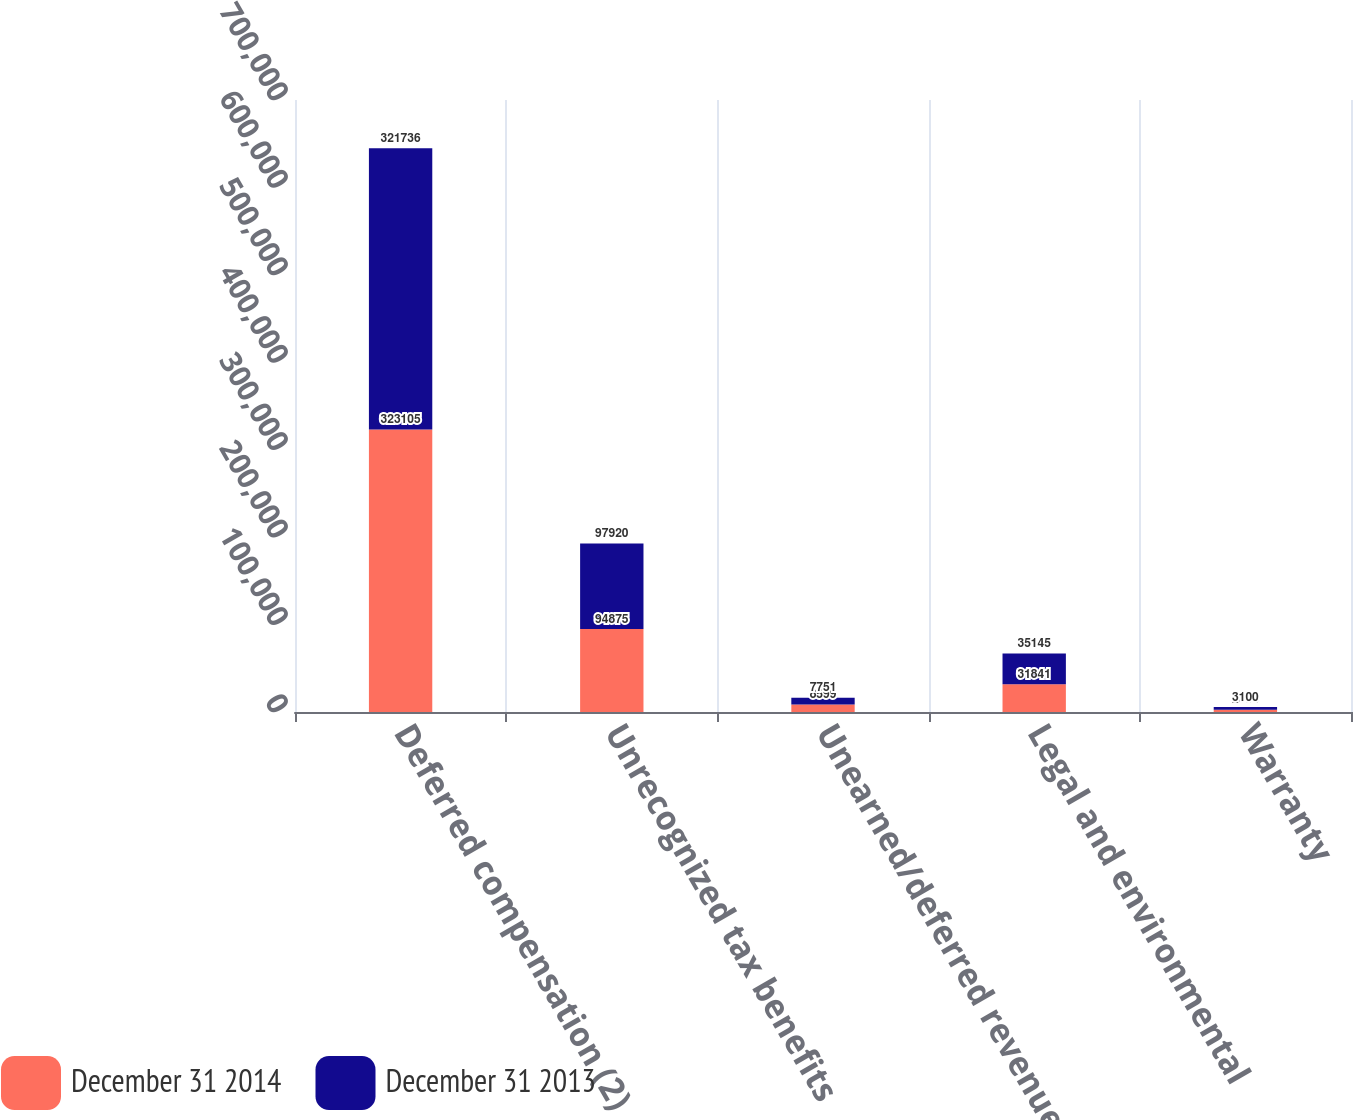<chart> <loc_0><loc_0><loc_500><loc_500><stacked_bar_chart><ecel><fcel>Deferred compensation (2)<fcel>Unrecognized tax benefits<fcel>Unearned/deferred revenue<fcel>Legal and environmental<fcel>Warranty<nl><fcel>December 31 2014<fcel>323105<fcel>94875<fcel>8599<fcel>31841<fcel>2684<nl><fcel>December 31 2013<fcel>321736<fcel>97920<fcel>7751<fcel>35145<fcel>3100<nl></chart> 